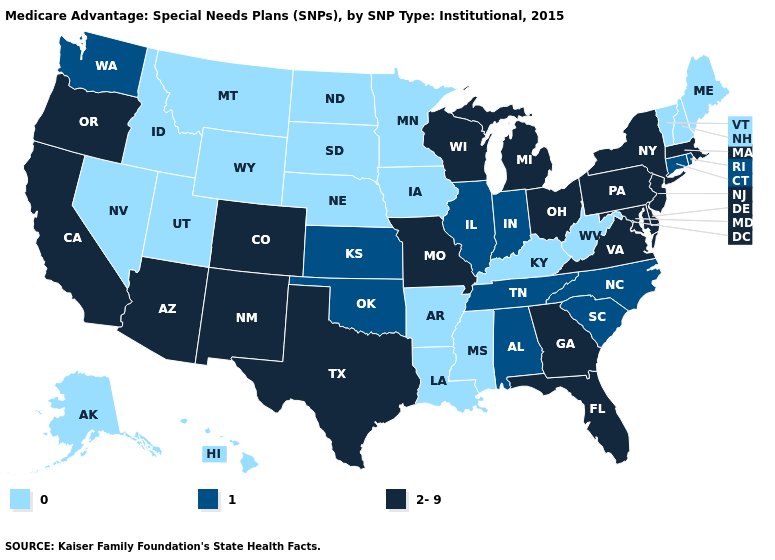Name the states that have a value in the range 0?
Give a very brief answer. Alaska, Arkansas, Hawaii, Iowa, Idaho, Kentucky, Louisiana, Maine, Minnesota, Mississippi, Montana, North Dakota, Nebraska, New Hampshire, Nevada, South Dakota, Utah, Vermont, West Virginia, Wyoming. Does Alaska have the highest value in the USA?
Be succinct. No. Name the states that have a value in the range 2-9?
Answer briefly. Arizona, California, Colorado, Delaware, Florida, Georgia, Massachusetts, Maryland, Michigan, Missouri, New Jersey, New Mexico, New York, Ohio, Oregon, Pennsylvania, Texas, Virginia, Wisconsin. Name the states that have a value in the range 2-9?
Concise answer only. Arizona, California, Colorado, Delaware, Florida, Georgia, Massachusetts, Maryland, Michigan, Missouri, New Jersey, New Mexico, New York, Ohio, Oregon, Pennsylvania, Texas, Virginia, Wisconsin. Among the states that border Washington , does Oregon have the highest value?
Quick response, please. Yes. Is the legend a continuous bar?
Write a very short answer. No. What is the value of Pennsylvania?
Keep it brief. 2-9. Name the states that have a value in the range 2-9?
Answer briefly. Arizona, California, Colorado, Delaware, Florida, Georgia, Massachusetts, Maryland, Michigan, Missouri, New Jersey, New Mexico, New York, Ohio, Oregon, Pennsylvania, Texas, Virginia, Wisconsin. What is the value of Vermont?
Quick response, please. 0. What is the highest value in the USA?
Short answer required. 2-9. What is the value of Colorado?
Give a very brief answer. 2-9. Which states have the highest value in the USA?
Be succinct. Arizona, California, Colorado, Delaware, Florida, Georgia, Massachusetts, Maryland, Michigan, Missouri, New Jersey, New Mexico, New York, Ohio, Oregon, Pennsylvania, Texas, Virginia, Wisconsin. What is the highest value in states that border North Dakota?
Write a very short answer. 0. Among the states that border Oregon , which have the highest value?
Keep it brief. California. 